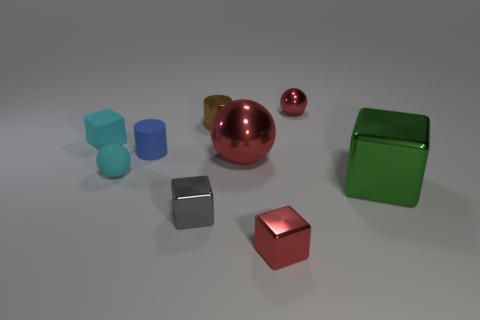Are there more small rubber objects right of the blue matte cylinder than brown metallic objects?
Your answer should be compact. No. What number of objects are either tiny cyan things that are behind the blue rubber object or blue matte objects?
Ensure brevity in your answer.  2. How many small red blocks are made of the same material as the brown cylinder?
Give a very brief answer. 1. What is the shape of the small object that is the same color as the tiny rubber block?
Provide a short and direct response. Sphere. Are there any small red objects that have the same shape as the blue thing?
Keep it short and to the point. No. There is a gray metal thing that is the same size as the cyan ball; what is its shape?
Your answer should be very brief. Cube. There is a tiny matte block; is it the same color as the small block right of the big red object?
Provide a short and direct response. No. There is a tiny cube that is behind the tiny blue rubber cylinder; what number of green objects are behind it?
Your answer should be very brief. 0. There is a ball that is to the right of the gray shiny cube and in front of the brown metal object; what size is it?
Make the answer very short. Large. Is there a ball that has the same size as the gray thing?
Your answer should be very brief. Yes. 